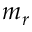<formula> <loc_0><loc_0><loc_500><loc_500>m _ { r }</formula> 